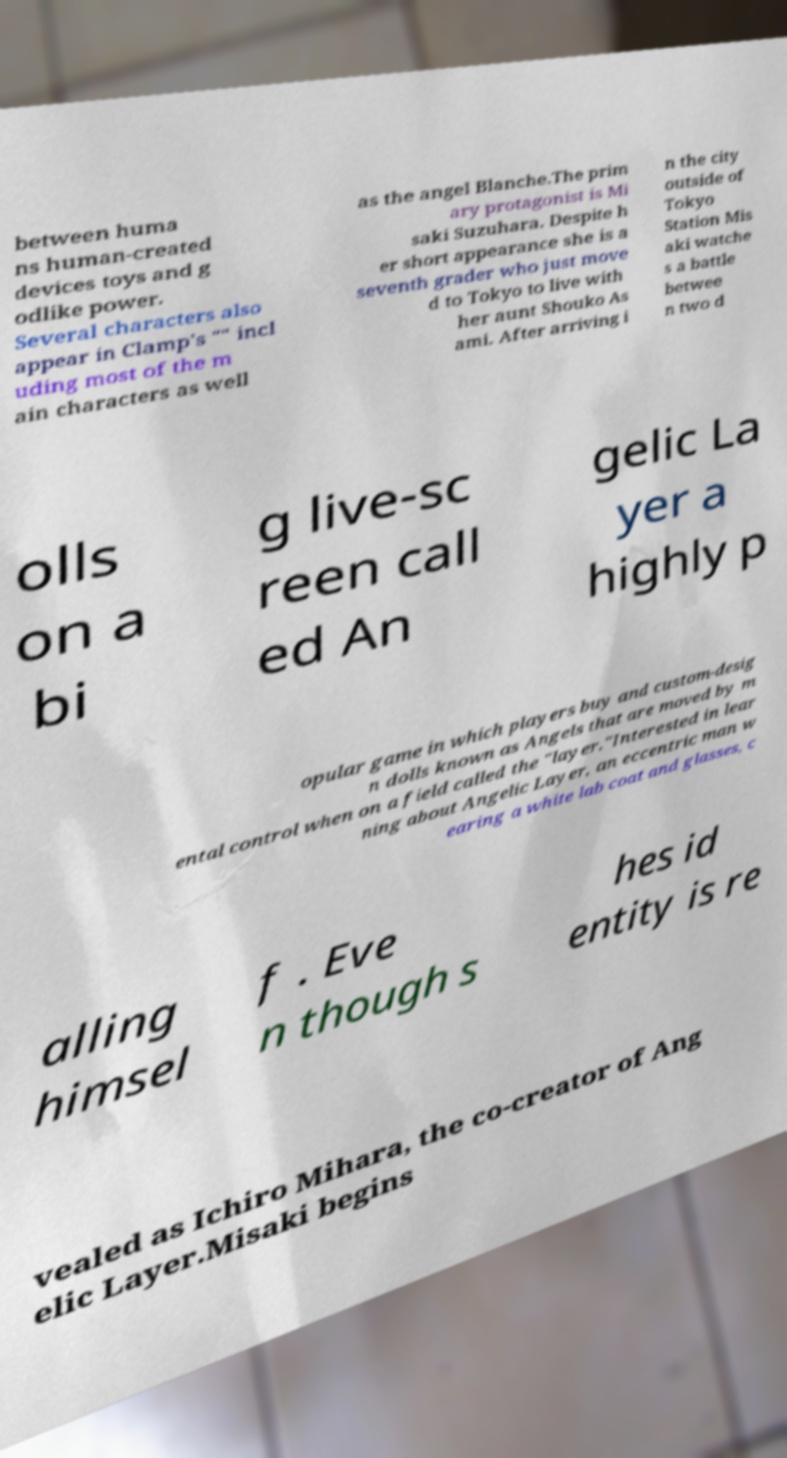What messages or text are displayed in this image? I need them in a readable, typed format. between huma ns human-created devices toys and g odlike power. Several characters also appear in Clamp's "" incl uding most of the m ain characters as well as the angel Blanche.The prim ary protagonist is Mi saki Suzuhara. Despite h er short appearance she is a seventh grader who just move d to Tokyo to live with her aunt Shouko As ami. After arriving i n the city outside of Tokyo Station Mis aki watche s a battle betwee n two d olls on a bi g live-sc reen call ed An gelic La yer a highly p opular game in which players buy and custom-desig n dolls known as Angels that are moved by m ental control when on a field called the "layer."Interested in lear ning about Angelic Layer, an eccentric man w earing a white lab coat and glasses, c alling himsel f . Eve n though s hes id entity is re vealed as Ichiro Mihara, the co-creator of Ang elic Layer.Misaki begins 